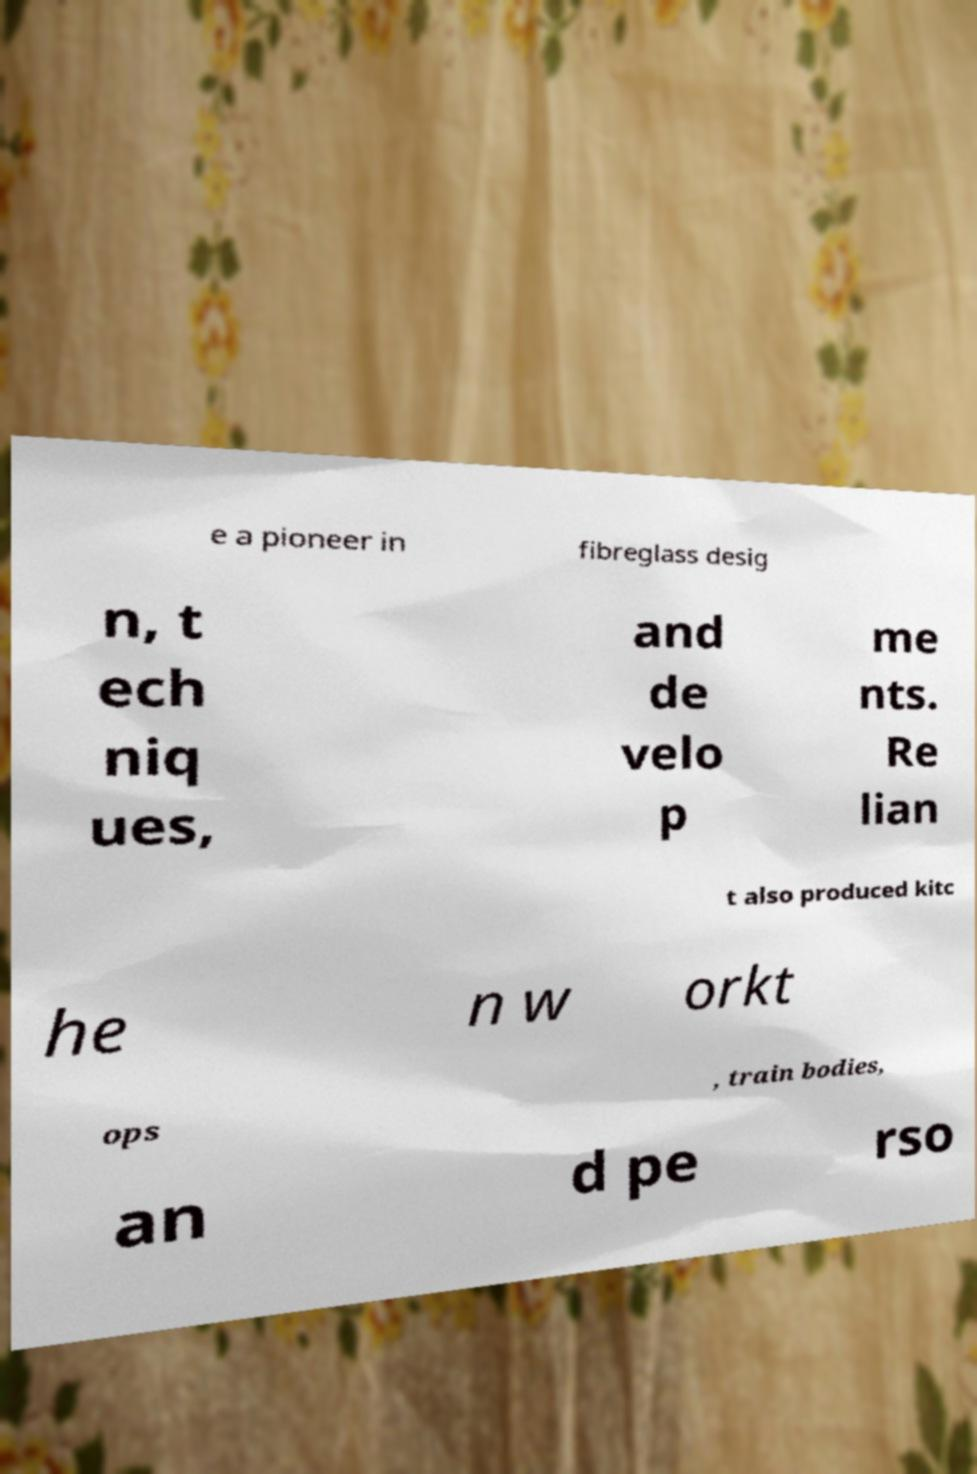Can you accurately transcribe the text from the provided image for me? e a pioneer in fibreglass desig n, t ech niq ues, and de velo p me nts. Re lian t also produced kitc he n w orkt ops , train bodies, an d pe rso 